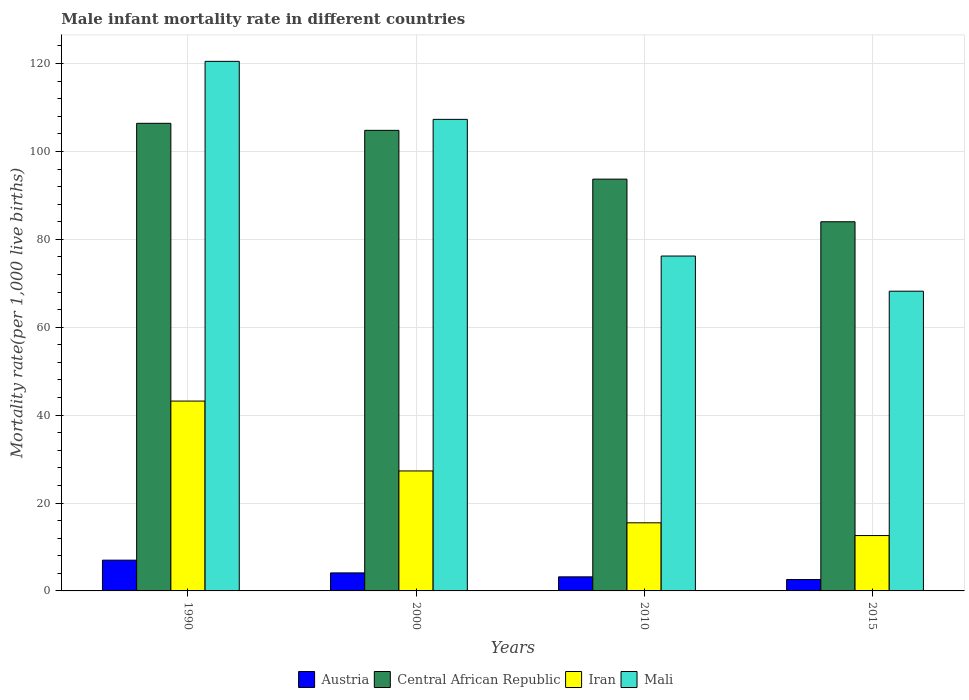Are the number of bars per tick equal to the number of legend labels?
Your answer should be very brief. Yes. Are the number of bars on each tick of the X-axis equal?
Your answer should be very brief. Yes. How many bars are there on the 1st tick from the left?
Your answer should be very brief. 4. How many bars are there on the 4th tick from the right?
Your response must be concise. 4. In how many cases, is the number of bars for a given year not equal to the number of legend labels?
Offer a terse response. 0. Across all years, what is the maximum male infant mortality rate in Iran?
Ensure brevity in your answer.  43.2. Across all years, what is the minimum male infant mortality rate in Mali?
Make the answer very short. 68.2. In which year was the male infant mortality rate in Central African Republic maximum?
Make the answer very short. 1990. In which year was the male infant mortality rate in Austria minimum?
Offer a very short reply. 2015. What is the total male infant mortality rate in Mali in the graph?
Provide a succinct answer. 372.2. What is the difference between the male infant mortality rate in Mali in 2000 and that in 2010?
Keep it short and to the point. 31.1. What is the difference between the male infant mortality rate in Austria in 2000 and the male infant mortality rate in Central African Republic in 1990?
Offer a terse response. -102.3. What is the average male infant mortality rate in Central African Republic per year?
Offer a terse response. 97.22. In the year 2000, what is the difference between the male infant mortality rate in Austria and male infant mortality rate in Mali?
Your response must be concise. -103.2. What is the ratio of the male infant mortality rate in Iran in 1990 to that in 2010?
Keep it short and to the point. 2.79. What is the difference between the highest and the second highest male infant mortality rate in Mali?
Offer a terse response. 13.2. What is the difference between the highest and the lowest male infant mortality rate in Iran?
Make the answer very short. 30.6. Is the sum of the male infant mortality rate in Mali in 2010 and 2015 greater than the maximum male infant mortality rate in Central African Republic across all years?
Your answer should be compact. Yes. What does the 2nd bar from the left in 2000 represents?
Offer a terse response. Central African Republic. How many bars are there?
Offer a terse response. 16. Are all the bars in the graph horizontal?
Offer a very short reply. No. What is the difference between two consecutive major ticks on the Y-axis?
Offer a very short reply. 20. Are the values on the major ticks of Y-axis written in scientific E-notation?
Offer a terse response. No. Does the graph contain any zero values?
Keep it short and to the point. No. Does the graph contain grids?
Provide a succinct answer. Yes. Where does the legend appear in the graph?
Ensure brevity in your answer.  Bottom center. How many legend labels are there?
Give a very brief answer. 4. What is the title of the graph?
Offer a terse response. Male infant mortality rate in different countries. What is the label or title of the Y-axis?
Ensure brevity in your answer.  Mortality rate(per 1,0 live births). What is the Mortality rate(per 1,000 live births) of Central African Republic in 1990?
Ensure brevity in your answer.  106.4. What is the Mortality rate(per 1,000 live births) in Iran in 1990?
Your answer should be very brief. 43.2. What is the Mortality rate(per 1,000 live births) of Mali in 1990?
Give a very brief answer. 120.5. What is the Mortality rate(per 1,000 live births) of Austria in 2000?
Keep it short and to the point. 4.1. What is the Mortality rate(per 1,000 live births) in Central African Republic in 2000?
Provide a short and direct response. 104.8. What is the Mortality rate(per 1,000 live births) in Iran in 2000?
Offer a very short reply. 27.3. What is the Mortality rate(per 1,000 live births) of Mali in 2000?
Offer a terse response. 107.3. What is the Mortality rate(per 1,000 live births) of Austria in 2010?
Offer a very short reply. 3.2. What is the Mortality rate(per 1,000 live births) in Central African Republic in 2010?
Give a very brief answer. 93.7. What is the Mortality rate(per 1,000 live births) of Mali in 2010?
Your answer should be compact. 76.2. What is the Mortality rate(per 1,000 live births) in Austria in 2015?
Keep it short and to the point. 2.6. What is the Mortality rate(per 1,000 live births) in Central African Republic in 2015?
Offer a terse response. 84. What is the Mortality rate(per 1,000 live births) in Iran in 2015?
Your answer should be compact. 12.6. What is the Mortality rate(per 1,000 live births) of Mali in 2015?
Provide a succinct answer. 68.2. Across all years, what is the maximum Mortality rate(per 1,000 live births) in Central African Republic?
Provide a short and direct response. 106.4. Across all years, what is the maximum Mortality rate(per 1,000 live births) in Iran?
Offer a terse response. 43.2. Across all years, what is the maximum Mortality rate(per 1,000 live births) in Mali?
Ensure brevity in your answer.  120.5. Across all years, what is the minimum Mortality rate(per 1,000 live births) in Central African Republic?
Give a very brief answer. 84. Across all years, what is the minimum Mortality rate(per 1,000 live births) in Iran?
Your answer should be very brief. 12.6. Across all years, what is the minimum Mortality rate(per 1,000 live births) of Mali?
Offer a terse response. 68.2. What is the total Mortality rate(per 1,000 live births) in Central African Republic in the graph?
Your answer should be compact. 388.9. What is the total Mortality rate(per 1,000 live births) of Iran in the graph?
Ensure brevity in your answer.  98.6. What is the total Mortality rate(per 1,000 live births) in Mali in the graph?
Keep it short and to the point. 372.2. What is the difference between the Mortality rate(per 1,000 live births) in Austria in 1990 and that in 2000?
Give a very brief answer. 2.9. What is the difference between the Mortality rate(per 1,000 live births) of Iran in 1990 and that in 2000?
Your answer should be very brief. 15.9. What is the difference between the Mortality rate(per 1,000 live births) in Iran in 1990 and that in 2010?
Provide a succinct answer. 27.7. What is the difference between the Mortality rate(per 1,000 live births) of Mali in 1990 and that in 2010?
Offer a very short reply. 44.3. What is the difference between the Mortality rate(per 1,000 live births) of Austria in 1990 and that in 2015?
Provide a succinct answer. 4.4. What is the difference between the Mortality rate(per 1,000 live births) in Central African Republic in 1990 and that in 2015?
Keep it short and to the point. 22.4. What is the difference between the Mortality rate(per 1,000 live births) of Iran in 1990 and that in 2015?
Provide a short and direct response. 30.6. What is the difference between the Mortality rate(per 1,000 live births) in Mali in 1990 and that in 2015?
Provide a short and direct response. 52.3. What is the difference between the Mortality rate(per 1,000 live births) of Austria in 2000 and that in 2010?
Give a very brief answer. 0.9. What is the difference between the Mortality rate(per 1,000 live births) of Central African Republic in 2000 and that in 2010?
Keep it short and to the point. 11.1. What is the difference between the Mortality rate(per 1,000 live births) in Mali in 2000 and that in 2010?
Provide a short and direct response. 31.1. What is the difference between the Mortality rate(per 1,000 live births) in Central African Republic in 2000 and that in 2015?
Make the answer very short. 20.8. What is the difference between the Mortality rate(per 1,000 live births) of Mali in 2000 and that in 2015?
Offer a terse response. 39.1. What is the difference between the Mortality rate(per 1,000 live births) of Austria in 2010 and that in 2015?
Your answer should be compact. 0.6. What is the difference between the Mortality rate(per 1,000 live births) of Central African Republic in 2010 and that in 2015?
Make the answer very short. 9.7. What is the difference between the Mortality rate(per 1,000 live births) in Iran in 2010 and that in 2015?
Your answer should be compact. 2.9. What is the difference between the Mortality rate(per 1,000 live births) in Austria in 1990 and the Mortality rate(per 1,000 live births) in Central African Republic in 2000?
Give a very brief answer. -97.8. What is the difference between the Mortality rate(per 1,000 live births) in Austria in 1990 and the Mortality rate(per 1,000 live births) in Iran in 2000?
Your answer should be compact. -20.3. What is the difference between the Mortality rate(per 1,000 live births) of Austria in 1990 and the Mortality rate(per 1,000 live births) of Mali in 2000?
Your answer should be compact. -100.3. What is the difference between the Mortality rate(per 1,000 live births) in Central African Republic in 1990 and the Mortality rate(per 1,000 live births) in Iran in 2000?
Your response must be concise. 79.1. What is the difference between the Mortality rate(per 1,000 live births) in Central African Republic in 1990 and the Mortality rate(per 1,000 live births) in Mali in 2000?
Your response must be concise. -0.9. What is the difference between the Mortality rate(per 1,000 live births) of Iran in 1990 and the Mortality rate(per 1,000 live births) of Mali in 2000?
Your response must be concise. -64.1. What is the difference between the Mortality rate(per 1,000 live births) of Austria in 1990 and the Mortality rate(per 1,000 live births) of Central African Republic in 2010?
Offer a terse response. -86.7. What is the difference between the Mortality rate(per 1,000 live births) of Austria in 1990 and the Mortality rate(per 1,000 live births) of Mali in 2010?
Keep it short and to the point. -69.2. What is the difference between the Mortality rate(per 1,000 live births) in Central African Republic in 1990 and the Mortality rate(per 1,000 live births) in Iran in 2010?
Provide a succinct answer. 90.9. What is the difference between the Mortality rate(per 1,000 live births) in Central African Republic in 1990 and the Mortality rate(per 1,000 live births) in Mali in 2010?
Offer a very short reply. 30.2. What is the difference between the Mortality rate(per 1,000 live births) in Iran in 1990 and the Mortality rate(per 1,000 live births) in Mali in 2010?
Your response must be concise. -33. What is the difference between the Mortality rate(per 1,000 live births) of Austria in 1990 and the Mortality rate(per 1,000 live births) of Central African Republic in 2015?
Ensure brevity in your answer.  -77. What is the difference between the Mortality rate(per 1,000 live births) in Austria in 1990 and the Mortality rate(per 1,000 live births) in Mali in 2015?
Make the answer very short. -61.2. What is the difference between the Mortality rate(per 1,000 live births) in Central African Republic in 1990 and the Mortality rate(per 1,000 live births) in Iran in 2015?
Your response must be concise. 93.8. What is the difference between the Mortality rate(per 1,000 live births) of Central African Republic in 1990 and the Mortality rate(per 1,000 live births) of Mali in 2015?
Your answer should be very brief. 38.2. What is the difference between the Mortality rate(per 1,000 live births) in Iran in 1990 and the Mortality rate(per 1,000 live births) in Mali in 2015?
Offer a very short reply. -25. What is the difference between the Mortality rate(per 1,000 live births) in Austria in 2000 and the Mortality rate(per 1,000 live births) in Central African Republic in 2010?
Provide a succinct answer. -89.6. What is the difference between the Mortality rate(per 1,000 live births) in Austria in 2000 and the Mortality rate(per 1,000 live births) in Mali in 2010?
Give a very brief answer. -72.1. What is the difference between the Mortality rate(per 1,000 live births) of Central African Republic in 2000 and the Mortality rate(per 1,000 live births) of Iran in 2010?
Provide a short and direct response. 89.3. What is the difference between the Mortality rate(per 1,000 live births) in Central African Republic in 2000 and the Mortality rate(per 1,000 live births) in Mali in 2010?
Provide a succinct answer. 28.6. What is the difference between the Mortality rate(per 1,000 live births) of Iran in 2000 and the Mortality rate(per 1,000 live births) of Mali in 2010?
Make the answer very short. -48.9. What is the difference between the Mortality rate(per 1,000 live births) in Austria in 2000 and the Mortality rate(per 1,000 live births) in Central African Republic in 2015?
Make the answer very short. -79.9. What is the difference between the Mortality rate(per 1,000 live births) of Austria in 2000 and the Mortality rate(per 1,000 live births) of Mali in 2015?
Keep it short and to the point. -64.1. What is the difference between the Mortality rate(per 1,000 live births) of Central African Republic in 2000 and the Mortality rate(per 1,000 live births) of Iran in 2015?
Keep it short and to the point. 92.2. What is the difference between the Mortality rate(per 1,000 live births) of Central African Republic in 2000 and the Mortality rate(per 1,000 live births) of Mali in 2015?
Provide a succinct answer. 36.6. What is the difference between the Mortality rate(per 1,000 live births) of Iran in 2000 and the Mortality rate(per 1,000 live births) of Mali in 2015?
Your answer should be very brief. -40.9. What is the difference between the Mortality rate(per 1,000 live births) in Austria in 2010 and the Mortality rate(per 1,000 live births) in Central African Republic in 2015?
Your answer should be compact. -80.8. What is the difference between the Mortality rate(per 1,000 live births) in Austria in 2010 and the Mortality rate(per 1,000 live births) in Iran in 2015?
Your answer should be compact. -9.4. What is the difference between the Mortality rate(per 1,000 live births) of Austria in 2010 and the Mortality rate(per 1,000 live births) of Mali in 2015?
Your answer should be very brief. -65. What is the difference between the Mortality rate(per 1,000 live births) in Central African Republic in 2010 and the Mortality rate(per 1,000 live births) in Iran in 2015?
Your response must be concise. 81.1. What is the difference between the Mortality rate(per 1,000 live births) in Central African Republic in 2010 and the Mortality rate(per 1,000 live births) in Mali in 2015?
Your response must be concise. 25.5. What is the difference between the Mortality rate(per 1,000 live births) of Iran in 2010 and the Mortality rate(per 1,000 live births) of Mali in 2015?
Make the answer very short. -52.7. What is the average Mortality rate(per 1,000 live births) in Austria per year?
Offer a very short reply. 4.22. What is the average Mortality rate(per 1,000 live births) in Central African Republic per year?
Your answer should be very brief. 97.22. What is the average Mortality rate(per 1,000 live births) in Iran per year?
Keep it short and to the point. 24.65. What is the average Mortality rate(per 1,000 live births) in Mali per year?
Keep it short and to the point. 93.05. In the year 1990, what is the difference between the Mortality rate(per 1,000 live births) of Austria and Mortality rate(per 1,000 live births) of Central African Republic?
Keep it short and to the point. -99.4. In the year 1990, what is the difference between the Mortality rate(per 1,000 live births) of Austria and Mortality rate(per 1,000 live births) of Iran?
Provide a succinct answer. -36.2. In the year 1990, what is the difference between the Mortality rate(per 1,000 live births) in Austria and Mortality rate(per 1,000 live births) in Mali?
Provide a succinct answer. -113.5. In the year 1990, what is the difference between the Mortality rate(per 1,000 live births) of Central African Republic and Mortality rate(per 1,000 live births) of Iran?
Ensure brevity in your answer.  63.2. In the year 1990, what is the difference between the Mortality rate(per 1,000 live births) in Central African Republic and Mortality rate(per 1,000 live births) in Mali?
Your answer should be very brief. -14.1. In the year 1990, what is the difference between the Mortality rate(per 1,000 live births) in Iran and Mortality rate(per 1,000 live births) in Mali?
Offer a very short reply. -77.3. In the year 2000, what is the difference between the Mortality rate(per 1,000 live births) in Austria and Mortality rate(per 1,000 live births) in Central African Republic?
Offer a terse response. -100.7. In the year 2000, what is the difference between the Mortality rate(per 1,000 live births) of Austria and Mortality rate(per 1,000 live births) of Iran?
Keep it short and to the point. -23.2. In the year 2000, what is the difference between the Mortality rate(per 1,000 live births) in Austria and Mortality rate(per 1,000 live births) in Mali?
Make the answer very short. -103.2. In the year 2000, what is the difference between the Mortality rate(per 1,000 live births) in Central African Republic and Mortality rate(per 1,000 live births) in Iran?
Keep it short and to the point. 77.5. In the year 2000, what is the difference between the Mortality rate(per 1,000 live births) in Central African Republic and Mortality rate(per 1,000 live births) in Mali?
Give a very brief answer. -2.5. In the year 2000, what is the difference between the Mortality rate(per 1,000 live births) of Iran and Mortality rate(per 1,000 live births) of Mali?
Ensure brevity in your answer.  -80. In the year 2010, what is the difference between the Mortality rate(per 1,000 live births) in Austria and Mortality rate(per 1,000 live births) in Central African Republic?
Provide a short and direct response. -90.5. In the year 2010, what is the difference between the Mortality rate(per 1,000 live births) of Austria and Mortality rate(per 1,000 live births) of Mali?
Keep it short and to the point. -73. In the year 2010, what is the difference between the Mortality rate(per 1,000 live births) in Central African Republic and Mortality rate(per 1,000 live births) in Iran?
Offer a very short reply. 78.2. In the year 2010, what is the difference between the Mortality rate(per 1,000 live births) in Central African Republic and Mortality rate(per 1,000 live births) in Mali?
Your response must be concise. 17.5. In the year 2010, what is the difference between the Mortality rate(per 1,000 live births) in Iran and Mortality rate(per 1,000 live births) in Mali?
Ensure brevity in your answer.  -60.7. In the year 2015, what is the difference between the Mortality rate(per 1,000 live births) of Austria and Mortality rate(per 1,000 live births) of Central African Republic?
Keep it short and to the point. -81.4. In the year 2015, what is the difference between the Mortality rate(per 1,000 live births) of Austria and Mortality rate(per 1,000 live births) of Mali?
Make the answer very short. -65.6. In the year 2015, what is the difference between the Mortality rate(per 1,000 live births) in Central African Republic and Mortality rate(per 1,000 live births) in Iran?
Make the answer very short. 71.4. In the year 2015, what is the difference between the Mortality rate(per 1,000 live births) in Iran and Mortality rate(per 1,000 live births) in Mali?
Provide a succinct answer. -55.6. What is the ratio of the Mortality rate(per 1,000 live births) in Austria in 1990 to that in 2000?
Keep it short and to the point. 1.71. What is the ratio of the Mortality rate(per 1,000 live births) of Central African Republic in 1990 to that in 2000?
Provide a short and direct response. 1.02. What is the ratio of the Mortality rate(per 1,000 live births) of Iran in 1990 to that in 2000?
Offer a very short reply. 1.58. What is the ratio of the Mortality rate(per 1,000 live births) in Mali in 1990 to that in 2000?
Offer a very short reply. 1.12. What is the ratio of the Mortality rate(per 1,000 live births) of Austria in 1990 to that in 2010?
Your response must be concise. 2.19. What is the ratio of the Mortality rate(per 1,000 live births) of Central African Republic in 1990 to that in 2010?
Your answer should be compact. 1.14. What is the ratio of the Mortality rate(per 1,000 live births) in Iran in 1990 to that in 2010?
Your response must be concise. 2.79. What is the ratio of the Mortality rate(per 1,000 live births) in Mali in 1990 to that in 2010?
Provide a succinct answer. 1.58. What is the ratio of the Mortality rate(per 1,000 live births) of Austria in 1990 to that in 2015?
Make the answer very short. 2.69. What is the ratio of the Mortality rate(per 1,000 live births) in Central African Republic in 1990 to that in 2015?
Give a very brief answer. 1.27. What is the ratio of the Mortality rate(per 1,000 live births) in Iran in 1990 to that in 2015?
Make the answer very short. 3.43. What is the ratio of the Mortality rate(per 1,000 live births) in Mali in 1990 to that in 2015?
Offer a terse response. 1.77. What is the ratio of the Mortality rate(per 1,000 live births) of Austria in 2000 to that in 2010?
Offer a very short reply. 1.28. What is the ratio of the Mortality rate(per 1,000 live births) in Central African Republic in 2000 to that in 2010?
Offer a very short reply. 1.12. What is the ratio of the Mortality rate(per 1,000 live births) of Iran in 2000 to that in 2010?
Your answer should be compact. 1.76. What is the ratio of the Mortality rate(per 1,000 live births) in Mali in 2000 to that in 2010?
Give a very brief answer. 1.41. What is the ratio of the Mortality rate(per 1,000 live births) in Austria in 2000 to that in 2015?
Ensure brevity in your answer.  1.58. What is the ratio of the Mortality rate(per 1,000 live births) of Central African Republic in 2000 to that in 2015?
Give a very brief answer. 1.25. What is the ratio of the Mortality rate(per 1,000 live births) in Iran in 2000 to that in 2015?
Offer a very short reply. 2.17. What is the ratio of the Mortality rate(per 1,000 live births) of Mali in 2000 to that in 2015?
Offer a terse response. 1.57. What is the ratio of the Mortality rate(per 1,000 live births) in Austria in 2010 to that in 2015?
Provide a short and direct response. 1.23. What is the ratio of the Mortality rate(per 1,000 live births) of Central African Republic in 2010 to that in 2015?
Your answer should be very brief. 1.12. What is the ratio of the Mortality rate(per 1,000 live births) in Iran in 2010 to that in 2015?
Give a very brief answer. 1.23. What is the ratio of the Mortality rate(per 1,000 live births) of Mali in 2010 to that in 2015?
Offer a terse response. 1.12. What is the difference between the highest and the second highest Mortality rate(per 1,000 live births) in Central African Republic?
Your answer should be compact. 1.6. What is the difference between the highest and the second highest Mortality rate(per 1,000 live births) in Iran?
Provide a succinct answer. 15.9. What is the difference between the highest and the lowest Mortality rate(per 1,000 live births) of Central African Republic?
Your response must be concise. 22.4. What is the difference between the highest and the lowest Mortality rate(per 1,000 live births) of Iran?
Offer a very short reply. 30.6. What is the difference between the highest and the lowest Mortality rate(per 1,000 live births) in Mali?
Give a very brief answer. 52.3. 